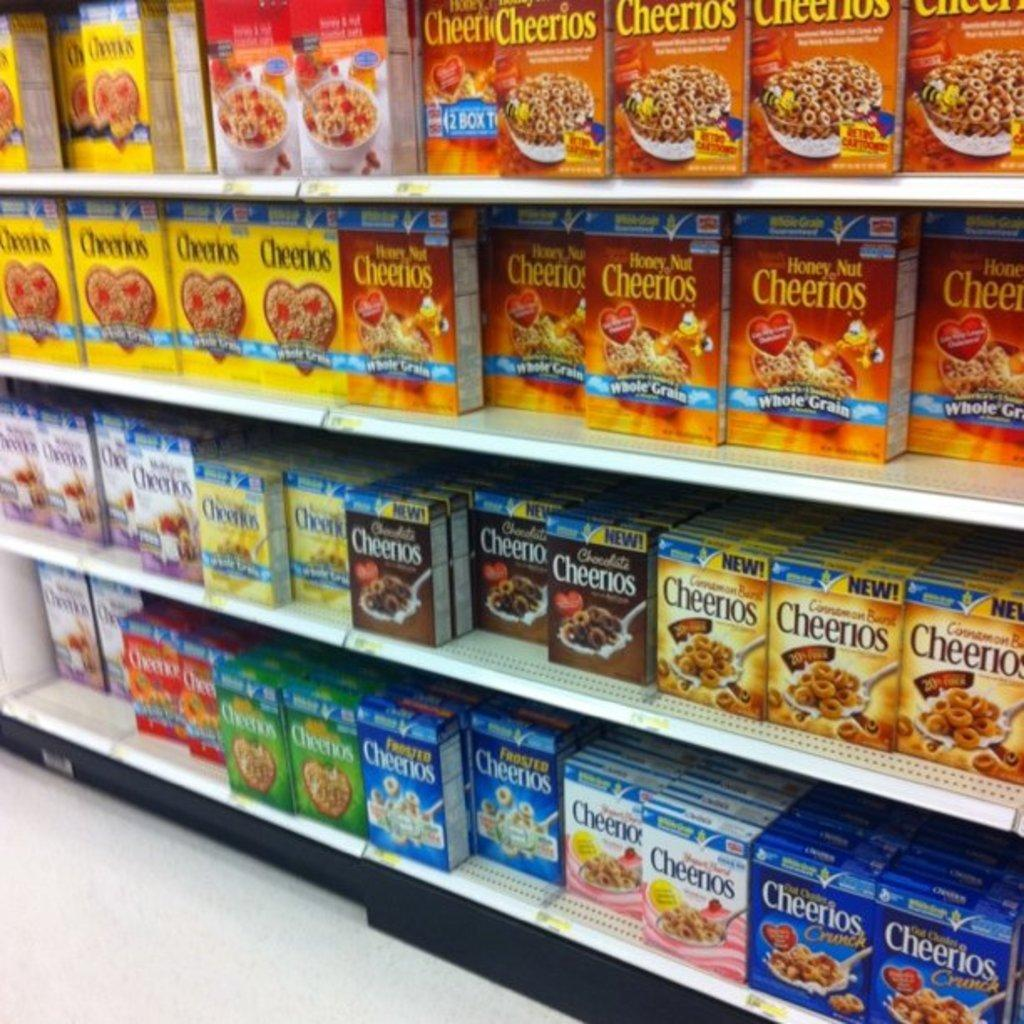<image>
Create a compact narrative representing the image presented. Cheeriors placed strategically in a supermarket for sale. 